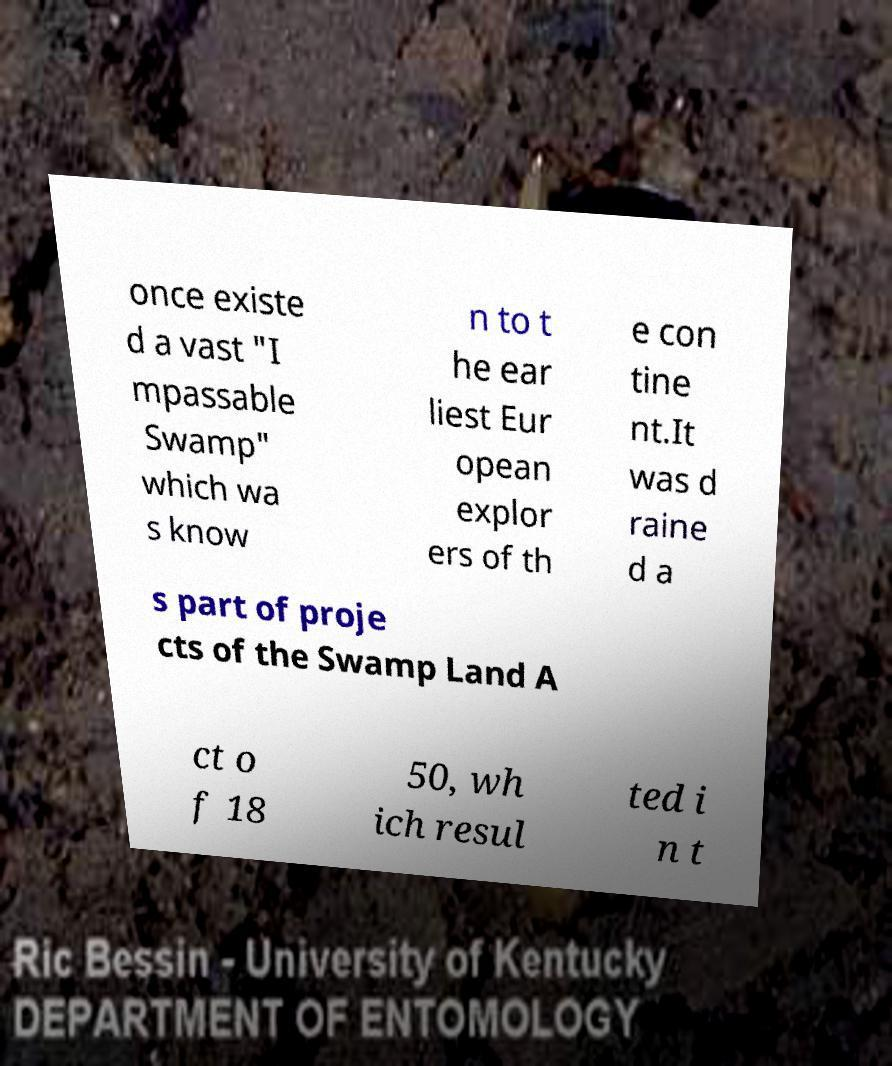Can you read and provide the text displayed in the image?This photo seems to have some interesting text. Can you extract and type it out for me? once existe d a vast "I mpassable Swamp" which wa s know n to t he ear liest Eur opean explor ers of th e con tine nt.It was d raine d a s part of proje cts of the Swamp Land A ct o f 18 50, wh ich resul ted i n t 